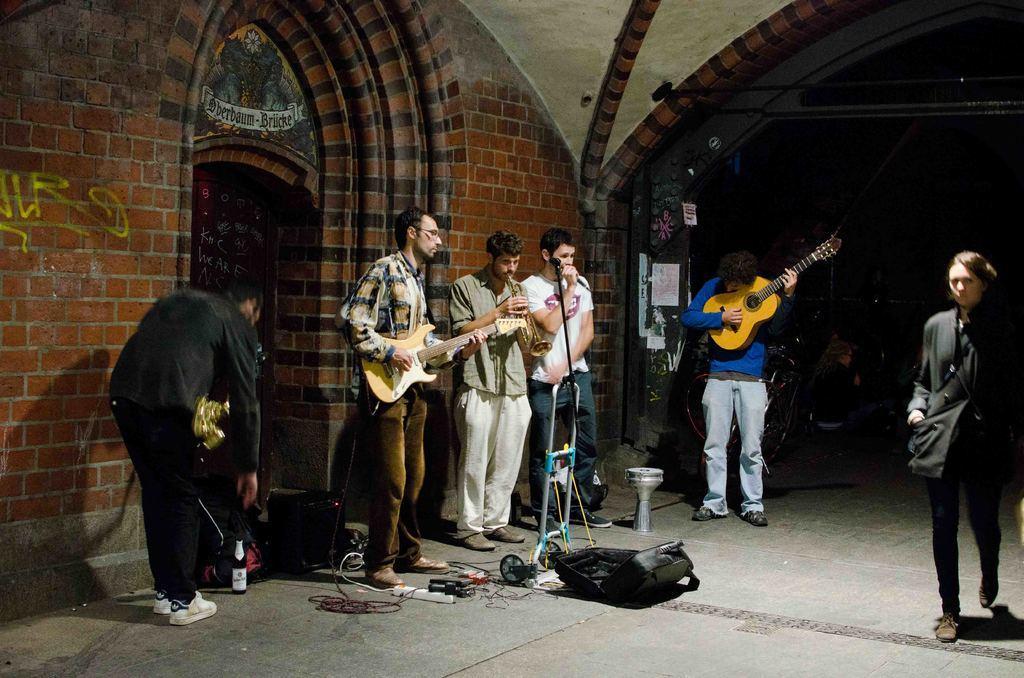Describe this image in one or two sentences. In this image there are six persons. On the right side the woman is walking and the man is playing a guitar. There all are standing on the floor. At the background there is a building on floor there is a bag and a bottle. 